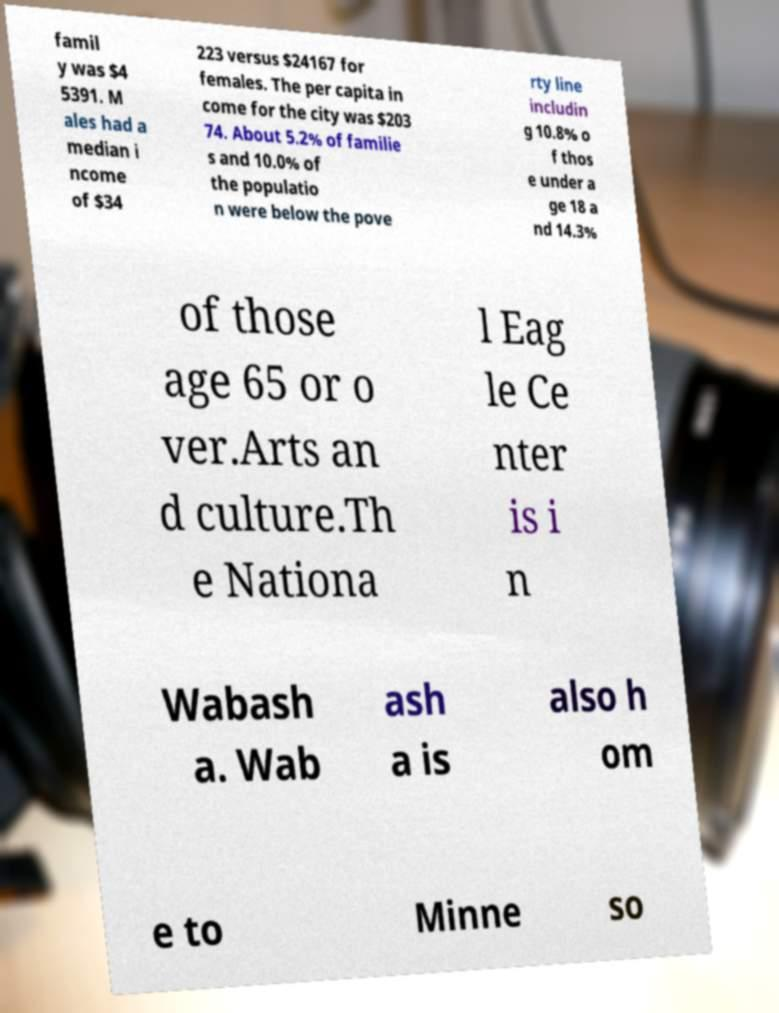What messages or text are displayed in this image? I need them in a readable, typed format. famil y was $4 5391. M ales had a median i ncome of $34 223 versus $24167 for females. The per capita in come for the city was $203 74. About 5.2% of familie s and 10.0% of the populatio n were below the pove rty line includin g 10.8% o f thos e under a ge 18 a nd 14.3% of those age 65 or o ver.Arts an d culture.Th e Nationa l Eag le Ce nter is i n Wabash a. Wab ash a is also h om e to Minne so 